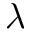<formula> <loc_0><loc_0><loc_500><loc_500>\lambda</formula> 